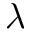<formula> <loc_0><loc_0><loc_500><loc_500>\lambda</formula> 